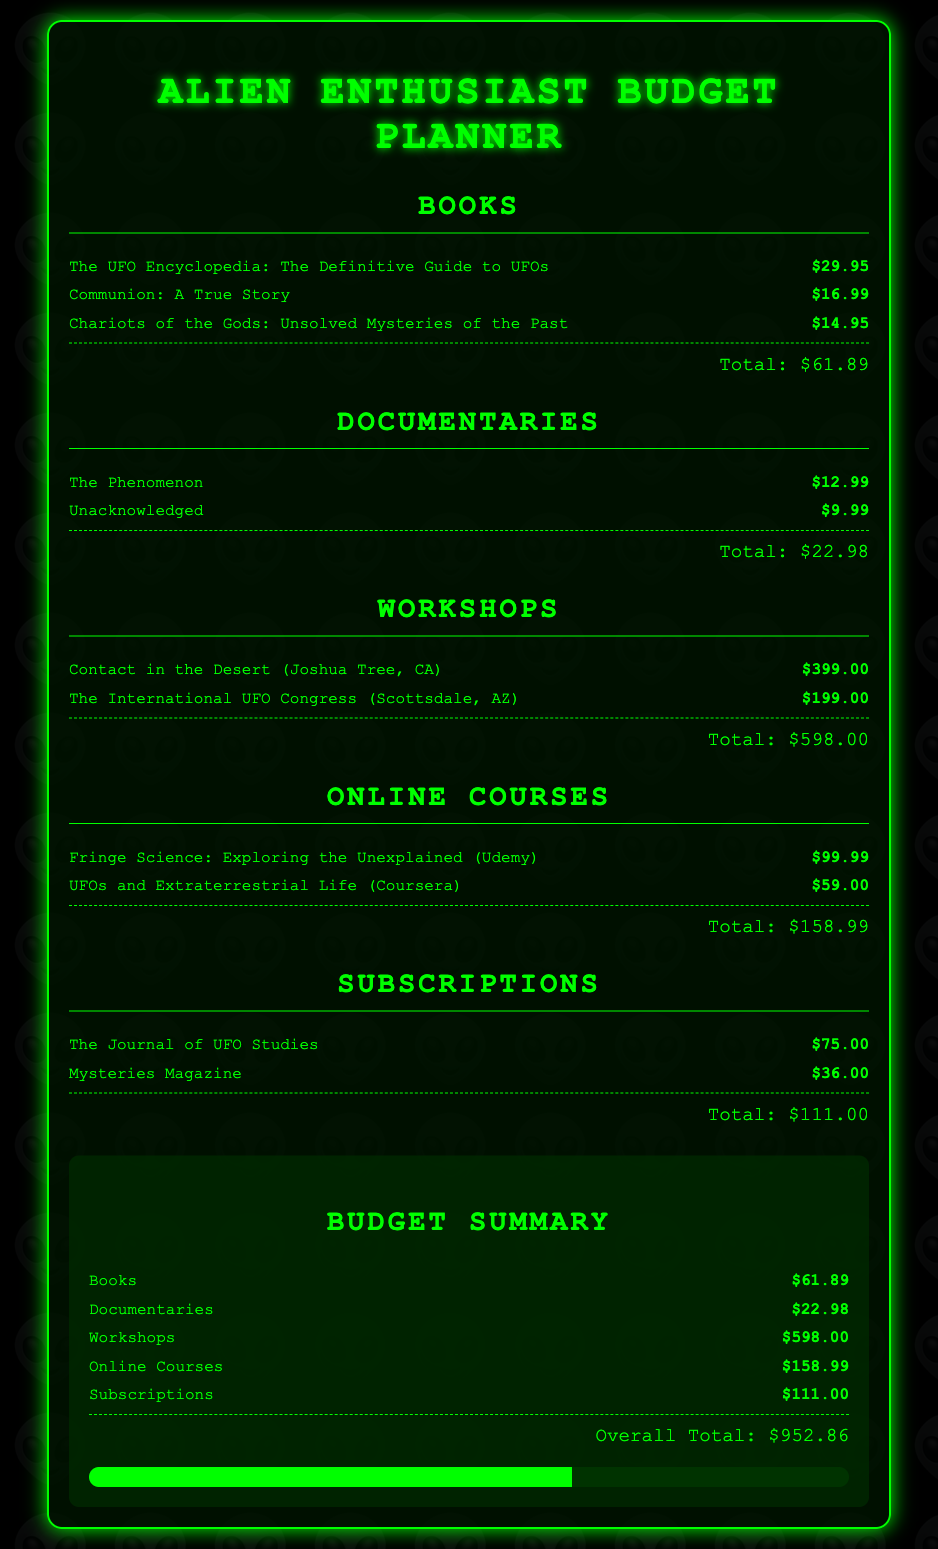What is the total cost for books? The total cost for books is listed in the document as the sum of individual book prices, which is $29.95 + $16.99 + $14.95 = $61.89.
Answer: $61.89 How much does "Communion: A True Story" cost? The cost of "Communion: A True Story" is provided in the document as $16.99.
Answer: $16.99 What is the total cost of documentaries? The total cost of documentaries is calculated by adding the individual documentary prices, resulting in $12.99 + $9.99 = $22.98.
Answer: $22.98 What is the most expensive workshop listed? The document states that "Contact in the Desert (Joshua Tree, CA)" costs $399.00, which is the highest price for workshops.
Answer: Contact in the Desert (Joshua Tree, CA) What is the overall budget total? The overall budget total is found at the bottom of the summary section, which sums all categories as $952.86.
Answer: $952.86 How much is the subscription to "Mysteries Magazine"? The subscription cost for "Mysteries Magazine" is detailed in the document as $36.00.
Answer: $36.00 Which online course costs more? The document lists "Fringe Science: Exploring the Unexplained (Udemy)" at $99.99, which is more expensive than "UFOs and Extraterrestrial Life (Coursera)" at $59.00.
Answer: $99.99 What is the total cost of subscriptions? The total for subscriptions is calculated by adding the costs of both subscriptions listed in the document: $75.00 + $36.00 = $111.00.
Answer: $111.00 